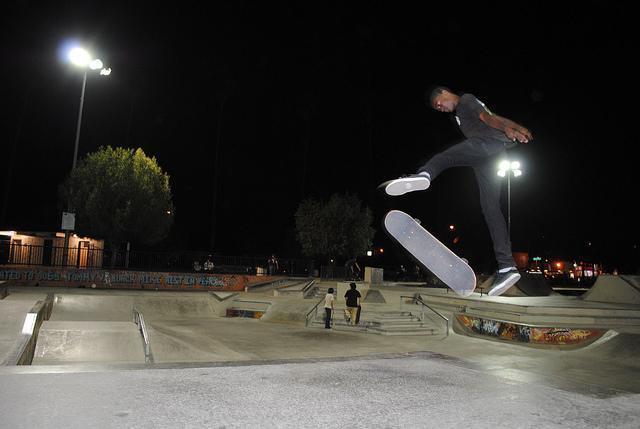How many suitcases are on the floor?
Give a very brief answer. 0. 